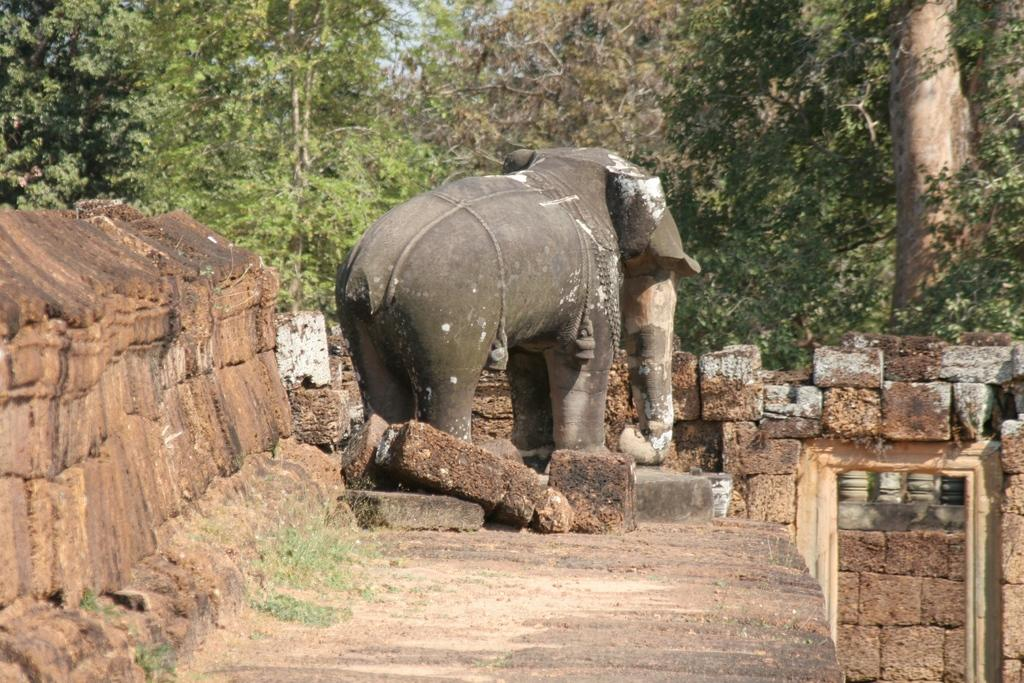What is the main subject of the image? There is a statue of an elephant in the image. What material is used to construct the statue? The statue is made of bricks, as there are many bricks visible in the image. What is located on the left side of the image? There is a brick wall on the left side of the image. What can be seen in the background of the image? There are trees in the background of the image. What type of string is being used to control the beast in the image? There is no beast or string present in the image; it features a statue of an elephant and a brick wall. 